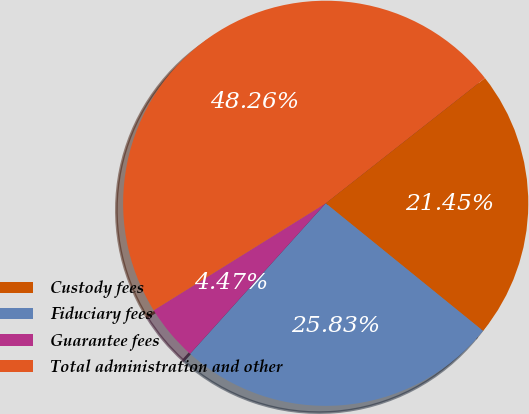<chart> <loc_0><loc_0><loc_500><loc_500><pie_chart><fcel>Custody fees<fcel>Fiduciary fees<fcel>Guarantee fees<fcel>Total administration and other<nl><fcel>21.45%<fcel>25.83%<fcel>4.47%<fcel>48.26%<nl></chart> 